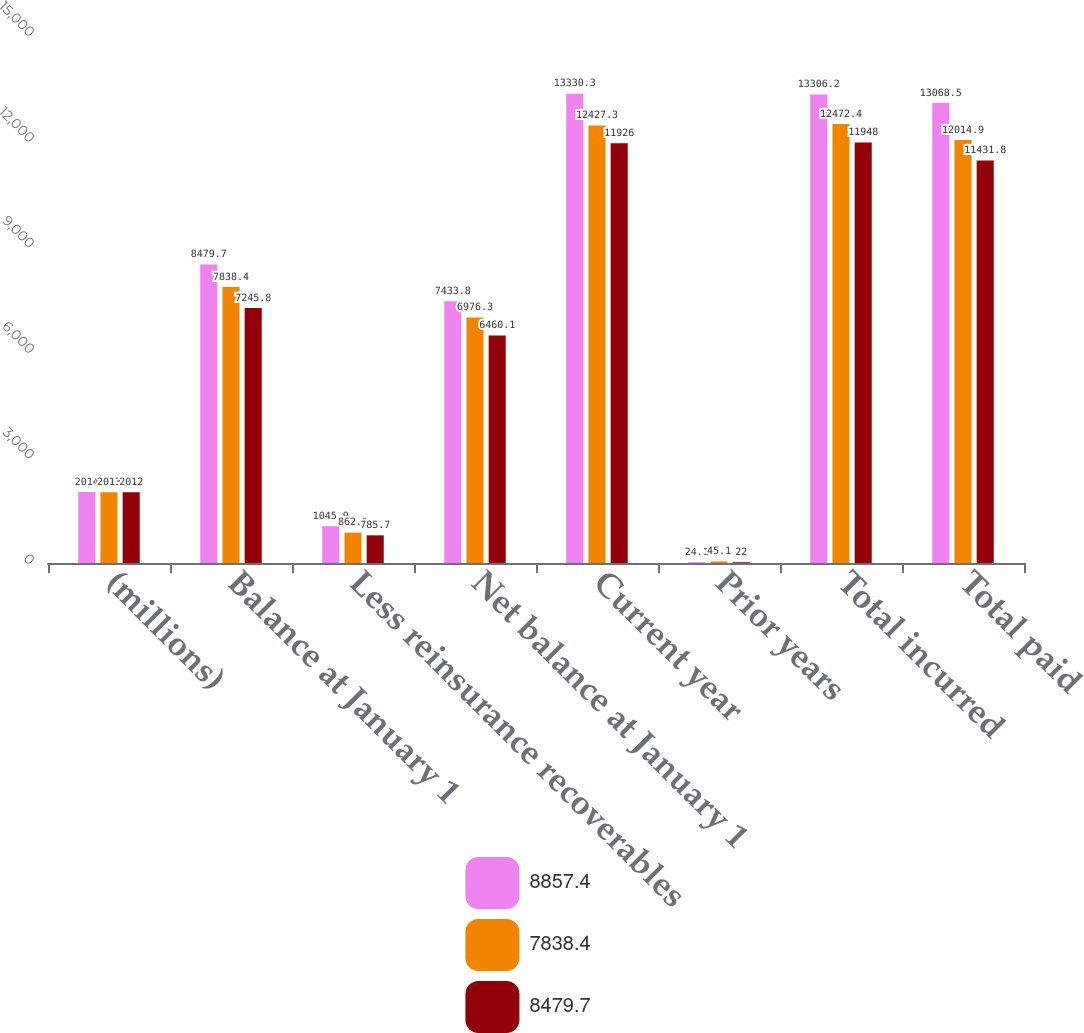<chart> <loc_0><loc_0><loc_500><loc_500><stacked_bar_chart><ecel><fcel>(millions)<fcel>Balance at January 1<fcel>Less reinsurance recoverables<fcel>Net balance at January 1<fcel>Current year<fcel>Prior years<fcel>Total incurred<fcel>Total paid<nl><fcel>8857.4<fcel>2014<fcel>8479.7<fcel>1045.9<fcel>7433.8<fcel>13330.3<fcel>24.1<fcel>13306.2<fcel>13068.5<nl><fcel>7838.4<fcel>2013<fcel>7838.4<fcel>862.1<fcel>6976.3<fcel>12427.3<fcel>45.1<fcel>12472.4<fcel>12014.9<nl><fcel>8479.7<fcel>2012<fcel>7245.8<fcel>785.7<fcel>6460.1<fcel>11926<fcel>22<fcel>11948<fcel>11431.8<nl></chart> 